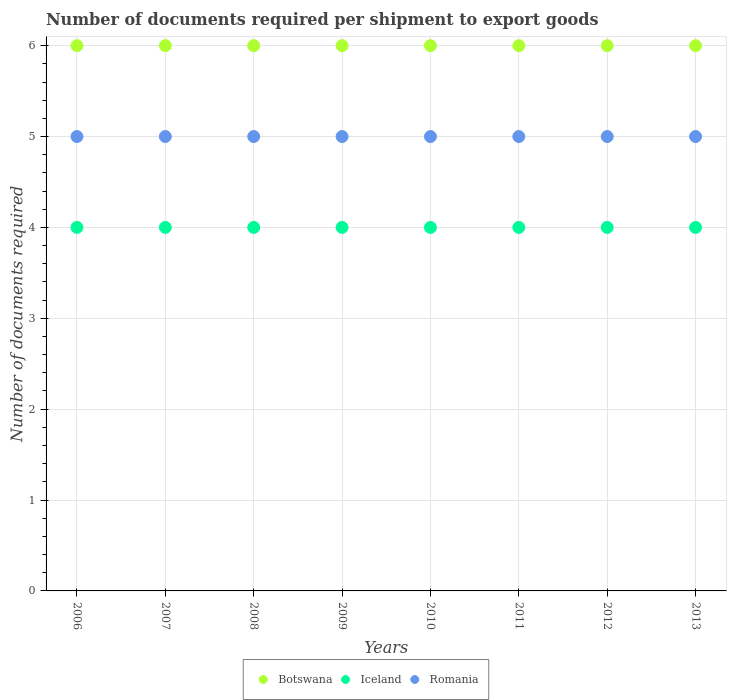Is the number of dotlines equal to the number of legend labels?
Provide a succinct answer. Yes. What is the number of documents required per shipment to export goods in Iceland in 2009?
Your answer should be very brief. 4. Across all years, what is the maximum number of documents required per shipment to export goods in Botswana?
Keep it short and to the point. 6. Across all years, what is the minimum number of documents required per shipment to export goods in Iceland?
Your answer should be compact. 4. In which year was the number of documents required per shipment to export goods in Romania minimum?
Provide a succinct answer. 2006. What is the total number of documents required per shipment to export goods in Iceland in the graph?
Your response must be concise. 32. What is the difference between the number of documents required per shipment to export goods in Botswana in 2013 and the number of documents required per shipment to export goods in Iceland in 2012?
Make the answer very short. 2. In the year 2009, what is the difference between the number of documents required per shipment to export goods in Romania and number of documents required per shipment to export goods in Botswana?
Provide a short and direct response. -1. In how many years, is the number of documents required per shipment to export goods in Romania greater than 4.8?
Provide a succinct answer. 8. What is the difference between the highest and the second highest number of documents required per shipment to export goods in Iceland?
Your answer should be very brief. 0. Is the sum of the number of documents required per shipment to export goods in Romania in 2009 and 2013 greater than the maximum number of documents required per shipment to export goods in Iceland across all years?
Your answer should be compact. Yes. Does the number of documents required per shipment to export goods in Romania monotonically increase over the years?
Make the answer very short. No. How many years are there in the graph?
Keep it short and to the point. 8. Does the graph contain grids?
Your answer should be very brief. Yes. Where does the legend appear in the graph?
Provide a succinct answer. Bottom center. How are the legend labels stacked?
Keep it short and to the point. Horizontal. What is the title of the graph?
Your response must be concise. Number of documents required per shipment to export goods. Does "Zimbabwe" appear as one of the legend labels in the graph?
Keep it short and to the point. No. What is the label or title of the X-axis?
Your response must be concise. Years. What is the label or title of the Y-axis?
Offer a very short reply. Number of documents required. What is the Number of documents required of Romania in 2006?
Your answer should be compact. 5. What is the Number of documents required of Botswana in 2007?
Give a very brief answer. 6. What is the Number of documents required of Iceland in 2007?
Make the answer very short. 4. What is the Number of documents required in Romania in 2008?
Your response must be concise. 5. What is the Number of documents required in Botswana in 2009?
Keep it short and to the point. 6. What is the Number of documents required of Botswana in 2010?
Provide a succinct answer. 6. What is the Number of documents required in Iceland in 2010?
Provide a short and direct response. 4. What is the Number of documents required in Iceland in 2011?
Ensure brevity in your answer.  4. What is the Number of documents required of Botswana in 2012?
Provide a succinct answer. 6. What is the Number of documents required of Iceland in 2012?
Give a very brief answer. 4. What is the Number of documents required in Romania in 2012?
Your answer should be compact. 5. What is the Number of documents required of Botswana in 2013?
Offer a terse response. 6. Across all years, what is the maximum Number of documents required in Botswana?
Make the answer very short. 6. Across all years, what is the minimum Number of documents required in Botswana?
Make the answer very short. 6. What is the total Number of documents required of Botswana in the graph?
Make the answer very short. 48. What is the difference between the Number of documents required of Iceland in 2006 and that in 2007?
Make the answer very short. 0. What is the difference between the Number of documents required in Romania in 2006 and that in 2007?
Make the answer very short. 0. What is the difference between the Number of documents required of Iceland in 2006 and that in 2011?
Offer a very short reply. 0. What is the difference between the Number of documents required in Botswana in 2006 and that in 2012?
Your answer should be compact. 0. What is the difference between the Number of documents required in Iceland in 2006 and that in 2012?
Your answer should be compact. 0. What is the difference between the Number of documents required in Romania in 2006 and that in 2012?
Make the answer very short. 0. What is the difference between the Number of documents required in Botswana in 2006 and that in 2013?
Provide a short and direct response. 0. What is the difference between the Number of documents required in Iceland in 2006 and that in 2013?
Make the answer very short. 0. What is the difference between the Number of documents required of Botswana in 2007 and that in 2008?
Ensure brevity in your answer.  0. What is the difference between the Number of documents required in Romania in 2007 and that in 2008?
Your answer should be compact. 0. What is the difference between the Number of documents required of Romania in 2007 and that in 2009?
Provide a succinct answer. 0. What is the difference between the Number of documents required of Iceland in 2007 and that in 2011?
Keep it short and to the point. 0. What is the difference between the Number of documents required of Romania in 2007 and that in 2011?
Offer a terse response. 0. What is the difference between the Number of documents required of Iceland in 2007 and that in 2012?
Ensure brevity in your answer.  0. What is the difference between the Number of documents required in Botswana in 2007 and that in 2013?
Offer a very short reply. 0. What is the difference between the Number of documents required in Botswana in 2008 and that in 2009?
Provide a succinct answer. 0. What is the difference between the Number of documents required in Romania in 2008 and that in 2009?
Your response must be concise. 0. What is the difference between the Number of documents required in Botswana in 2008 and that in 2010?
Your response must be concise. 0. What is the difference between the Number of documents required of Iceland in 2008 and that in 2010?
Provide a short and direct response. 0. What is the difference between the Number of documents required in Iceland in 2008 and that in 2011?
Your answer should be compact. 0. What is the difference between the Number of documents required in Romania in 2008 and that in 2011?
Keep it short and to the point. 0. What is the difference between the Number of documents required in Romania in 2008 and that in 2012?
Ensure brevity in your answer.  0. What is the difference between the Number of documents required in Botswana in 2008 and that in 2013?
Your answer should be compact. 0. What is the difference between the Number of documents required of Iceland in 2008 and that in 2013?
Your answer should be very brief. 0. What is the difference between the Number of documents required in Romania in 2008 and that in 2013?
Your answer should be compact. 0. What is the difference between the Number of documents required of Botswana in 2009 and that in 2010?
Make the answer very short. 0. What is the difference between the Number of documents required in Iceland in 2009 and that in 2010?
Your answer should be compact. 0. What is the difference between the Number of documents required in Romania in 2009 and that in 2010?
Offer a very short reply. 0. What is the difference between the Number of documents required in Botswana in 2009 and that in 2011?
Give a very brief answer. 0. What is the difference between the Number of documents required of Iceland in 2009 and that in 2011?
Keep it short and to the point. 0. What is the difference between the Number of documents required of Botswana in 2009 and that in 2012?
Your response must be concise. 0. What is the difference between the Number of documents required in Iceland in 2010 and that in 2011?
Your answer should be compact. 0. What is the difference between the Number of documents required of Romania in 2010 and that in 2011?
Your answer should be compact. 0. What is the difference between the Number of documents required of Iceland in 2010 and that in 2012?
Offer a very short reply. 0. What is the difference between the Number of documents required of Romania in 2010 and that in 2012?
Your response must be concise. 0. What is the difference between the Number of documents required of Botswana in 2011 and that in 2012?
Provide a succinct answer. 0. What is the difference between the Number of documents required in Iceland in 2011 and that in 2012?
Your response must be concise. 0. What is the difference between the Number of documents required of Romania in 2011 and that in 2012?
Ensure brevity in your answer.  0. What is the difference between the Number of documents required of Romania in 2011 and that in 2013?
Keep it short and to the point. 0. What is the difference between the Number of documents required of Botswana in 2012 and that in 2013?
Give a very brief answer. 0. What is the difference between the Number of documents required in Iceland in 2012 and that in 2013?
Keep it short and to the point. 0. What is the difference between the Number of documents required in Romania in 2012 and that in 2013?
Keep it short and to the point. 0. What is the difference between the Number of documents required in Botswana in 2006 and the Number of documents required in Iceland in 2007?
Ensure brevity in your answer.  2. What is the difference between the Number of documents required in Botswana in 2006 and the Number of documents required in Romania in 2007?
Provide a short and direct response. 1. What is the difference between the Number of documents required of Botswana in 2006 and the Number of documents required of Iceland in 2008?
Offer a very short reply. 2. What is the difference between the Number of documents required of Iceland in 2006 and the Number of documents required of Romania in 2008?
Your answer should be very brief. -1. What is the difference between the Number of documents required in Botswana in 2006 and the Number of documents required in Romania in 2009?
Your response must be concise. 1. What is the difference between the Number of documents required in Botswana in 2006 and the Number of documents required in Iceland in 2010?
Your answer should be very brief. 2. What is the difference between the Number of documents required in Iceland in 2006 and the Number of documents required in Romania in 2011?
Your response must be concise. -1. What is the difference between the Number of documents required of Botswana in 2006 and the Number of documents required of Romania in 2012?
Make the answer very short. 1. What is the difference between the Number of documents required in Iceland in 2006 and the Number of documents required in Romania in 2012?
Your answer should be very brief. -1. What is the difference between the Number of documents required in Botswana in 2006 and the Number of documents required in Romania in 2013?
Provide a succinct answer. 1. What is the difference between the Number of documents required in Iceland in 2006 and the Number of documents required in Romania in 2013?
Your answer should be very brief. -1. What is the difference between the Number of documents required of Botswana in 2007 and the Number of documents required of Iceland in 2008?
Make the answer very short. 2. What is the difference between the Number of documents required of Botswana in 2007 and the Number of documents required of Romania in 2008?
Provide a succinct answer. 1. What is the difference between the Number of documents required in Botswana in 2007 and the Number of documents required in Iceland in 2009?
Your answer should be very brief. 2. What is the difference between the Number of documents required in Botswana in 2007 and the Number of documents required in Romania in 2010?
Make the answer very short. 1. What is the difference between the Number of documents required in Botswana in 2007 and the Number of documents required in Iceland in 2011?
Provide a short and direct response. 2. What is the difference between the Number of documents required of Iceland in 2007 and the Number of documents required of Romania in 2011?
Your answer should be very brief. -1. What is the difference between the Number of documents required of Iceland in 2007 and the Number of documents required of Romania in 2012?
Your answer should be compact. -1. What is the difference between the Number of documents required of Botswana in 2007 and the Number of documents required of Romania in 2013?
Offer a very short reply. 1. What is the difference between the Number of documents required in Botswana in 2008 and the Number of documents required in Iceland in 2009?
Offer a very short reply. 2. What is the difference between the Number of documents required of Iceland in 2008 and the Number of documents required of Romania in 2009?
Give a very brief answer. -1. What is the difference between the Number of documents required of Botswana in 2008 and the Number of documents required of Romania in 2010?
Ensure brevity in your answer.  1. What is the difference between the Number of documents required in Botswana in 2008 and the Number of documents required in Romania in 2011?
Your answer should be compact. 1. What is the difference between the Number of documents required of Iceland in 2008 and the Number of documents required of Romania in 2011?
Offer a very short reply. -1. What is the difference between the Number of documents required of Iceland in 2008 and the Number of documents required of Romania in 2012?
Offer a very short reply. -1. What is the difference between the Number of documents required in Botswana in 2008 and the Number of documents required in Romania in 2013?
Provide a succinct answer. 1. What is the difference between the Number of documents required in Botswana in 2009 and the Number of documents required in Iceland in 2010?
Provide a short and direct response. 2. What is the difference between the Number of documents required in Botswana in 2009 and the Number of documents required in Iceland in 2012?
Give a very brief answer. 2. What is the difference between the Number of documents required in Botswana in 2009 and the Number of documents required in Romania in 2012?
Provide a short and direct response. 1. What is the difference between the Number of documents required in Iceland in 2009 and the Number of documents required in Romania in 2012?
Provide a short and direct response. -1. What is the difference between the Number of documents required in Botswana in 2009 and the Number of documents required in Iceland in 2013?
Ensure brevity in your answer.  2. What is the difference between the Number of documents required in Iceland in 2009 and the Number of documents required in Romania in 2013?
Your response must be concise. -1. What is the difference between the Number of documents required of Botswana in 2010 and the Number of documents required of Iceland in 2011?
Provide a succinct answer. 2. What is the difference between the Number of documents required of Botswana in 2010 and the Number of documents required of Romania in 2011?
Make the answer very short. 1. What is the difference between the Number of documents required of Iceland in 2010 and the Number of documents required of Romania in 2012?
Keep it short and to the point. -1. What is the difference between the Number of documents required of Botswana in 2011 and the Number of documents required of Iceland in 2012?
Provide a succinct answer. 2. What is the difference between the Number of documents required in Botswana in 2011 and the Number of documents required in Romania in 2012?
Give a very brief answer. 1. What is the difference between the Number of documents required of Iceland in 2011 and the Number of documents required of Romania in 2012?
Your answer should be very brief. -1. What is the difference between the Number of documents required in Iceland in 2012 and the Number of documents required in Romania in 2013?
Make the answer very short. -1. What is the average Number of documents required of Iceland per year?
Offer a terse response. 4. What is the average Number of documents required in Romania per year?
Provide a succinct answer. 5. In the year 2007, what is the difference between the Number of documents required of Botswana and Number of documents required of Iceland?
Your answer should be compact. 2. In the year 2007, what is the difference between the Number of documents required in Botswana and Number of documents required in Romania?
Make the answer very short. 1. In the year 2008, what is the difference between the Number of documents required in Botswana and Number of documents required in Iceland?
Provide a succinct answer. 2. In the year 2008, what is the difference between the Number of documents required of Iceland and Number of documents required of Romania?
Offer a very short reply. -1. In the year 2009, what is the difference between the Number of documents required of Botswana and Number of documents required of Romania?
Ensure brevity in your answer.  1. In the year 2010, what is the difference between the Number of documents required of Botswana and Number of documents required of Iceland?
Your answer should be compact. 2. In the year 2010, what is the difference between the Number of documents required of Botswana and Number of documents required of Romania?
Your answer should be compact. 1. In the year 2011, what is the difference between the Number of documents required of Botswana and Number of documents required of Iceland?
Provide a short and direct response. 2. In the year 2013, what is the difference between the Number of documents required in Botswana and Number of documents required in Iceland?
Provide a succinct answer. 2. In the year 2013, what is the difference between the Number of documents required of Botswana and Number of documents required of Romania?
Ensure brevity in your answer.  1. What is the ratio of the Number of documents required of Botswana in 2006 to that in 2007?
Provide a succinct answer. 1. What is the ratio of the Number of documents required of Romania in 2006 to that in 2008?
Give a very brief answer. 1. What is the ratio of the Number of documents required of Iceland in 2006 to that in 2009?
Make the answer very short. 1. What is the ratio of the Number of documents required of Romania in 2006 to that in 2009?
Offer a very short reply. 1. What is the ratio of the Number of documents required of Botswana in 2006 to that in 2010?
Give a very brief answer. 1. What is the ratio of the Number of documents required in Romania in 2006 to that in 2011?
Your answer should be compact. 1. What is the ratio of the Number of documents required of Iceland in 2006 to that in 2012?
Give a very brief answer. 1. What is the ratio of the Number of documents required in Romania in 2006 to that in 2012?
Your response must be concise. 1. What is the ratio of the Number of documents required in Romania in 2007 to that in 2008?
Offer a terse response. 1. What is the ratio of the Number of documents required of Iceland in 2007 to that in 2009?
Offer a terse response. 1. What is the ratio of the Number of documents required in Iceland in 2007 to that in 2010?
Give a very brief answer. 1. What is the ratio of the Number of documents required in Romania in 2007 to that in 2010?
Ensure brevity in your answer.  1. What is the ratio of the Number of documents required of Botswana in 2007 to that in 2011?
Offer a very short reply. 1. What is the ratio of the Number of documents required in Botswana in 2007 to that in 2012?
Make the answer very short. 1. What is the ratio of the Number of documents required in Iceland in 2007 to that in 2012?
Your answer should be very brief. 1. What is the ratio of the Number of documents required in Romania in 2007 to that in 2012?
Your answer should be very brief. 1. What is the ratio of the Number of documents required of Botswana in 2007 to that in 2013?
Keep it short and to the point. 1. What is the ratio of the Number of documents required in Iceland in 2007 to that in 2013?
Your response must be concise. 1. What is the ratio of the Number of documents required in Botswana in 2008 to that in 2009?
Offer a terse response. 1. What is the ratio of the Number of documents required of Iceland in 2008 to that in 2011?
Offer a very short reply. 1. What is the ratio of the Number of documents required in Romania in 2008 to that in 2011?
Provide a short and direct response. 1. What is the ratio of the Number of documents required in Iceland in 2008 to that in 2012?
Provide a succinct answer. 1. What is the ratio of the Number of documents required of Botswana in 2009 to that in 2010?
Offer a very short reply. 1. What is the ratio of the Number of documents required in Romania in 2009 to that in 2010?
Provide a short and direct response. 1. What is the ratio of the Number of documents required of Botswana in 2009 to that in 2011?
Offer a very short reply. 1. What is the ratio of the Number of documents required in Iceland in 2009 to that in 2011?
Your response must be concise. 1. What is the ratio of the Number of documents required of Romania in 2009 to that in 2011?
Your response must be concise. 1. What is the ratio of the Number of documents required of Romania in 2009 to that in 2012?
Keep it short and to the point. 1. What is the ratio of the Number of documents required in Iceland in 2010 to that in 2011?
Give a very brief answer. 1. What is the ratio of the Number of documents required in Botswana in 2010 to that in 2012?
Provide a succinct answer. 1. What is the ratio of the Number of documents required in Iceland in 2010 to that in 2012?
Offer a terse response. 1. What is the ratio of the Number of documents required of Iceland in 2010 to that in 2013?
Provide a succinct answer. 1. What is the ratio of the Number of documents required of Botswana in 2011 to that in 2012?
Your answer should be very brief. 1. What is the ratio of the Number of documents required of Romania in 2011 to that in 2012?
Offer a terse response. 1. What is the ratio of the Number of documents required of Botswana in 2011 to that in 2013?
Make the answer very short. 1. What is the ratio of the Number of documents required of Iceland in 2011 to that in 2013?
Offer a very short reply. 1. What is the ratio of the Number of documents required in Romania in 2012 to that in 2013?
Keep it short and to the point. 1. What is the difference between the highest and the lowest Number of documents required in Botswana?
Your answer should be very brief. 0. 